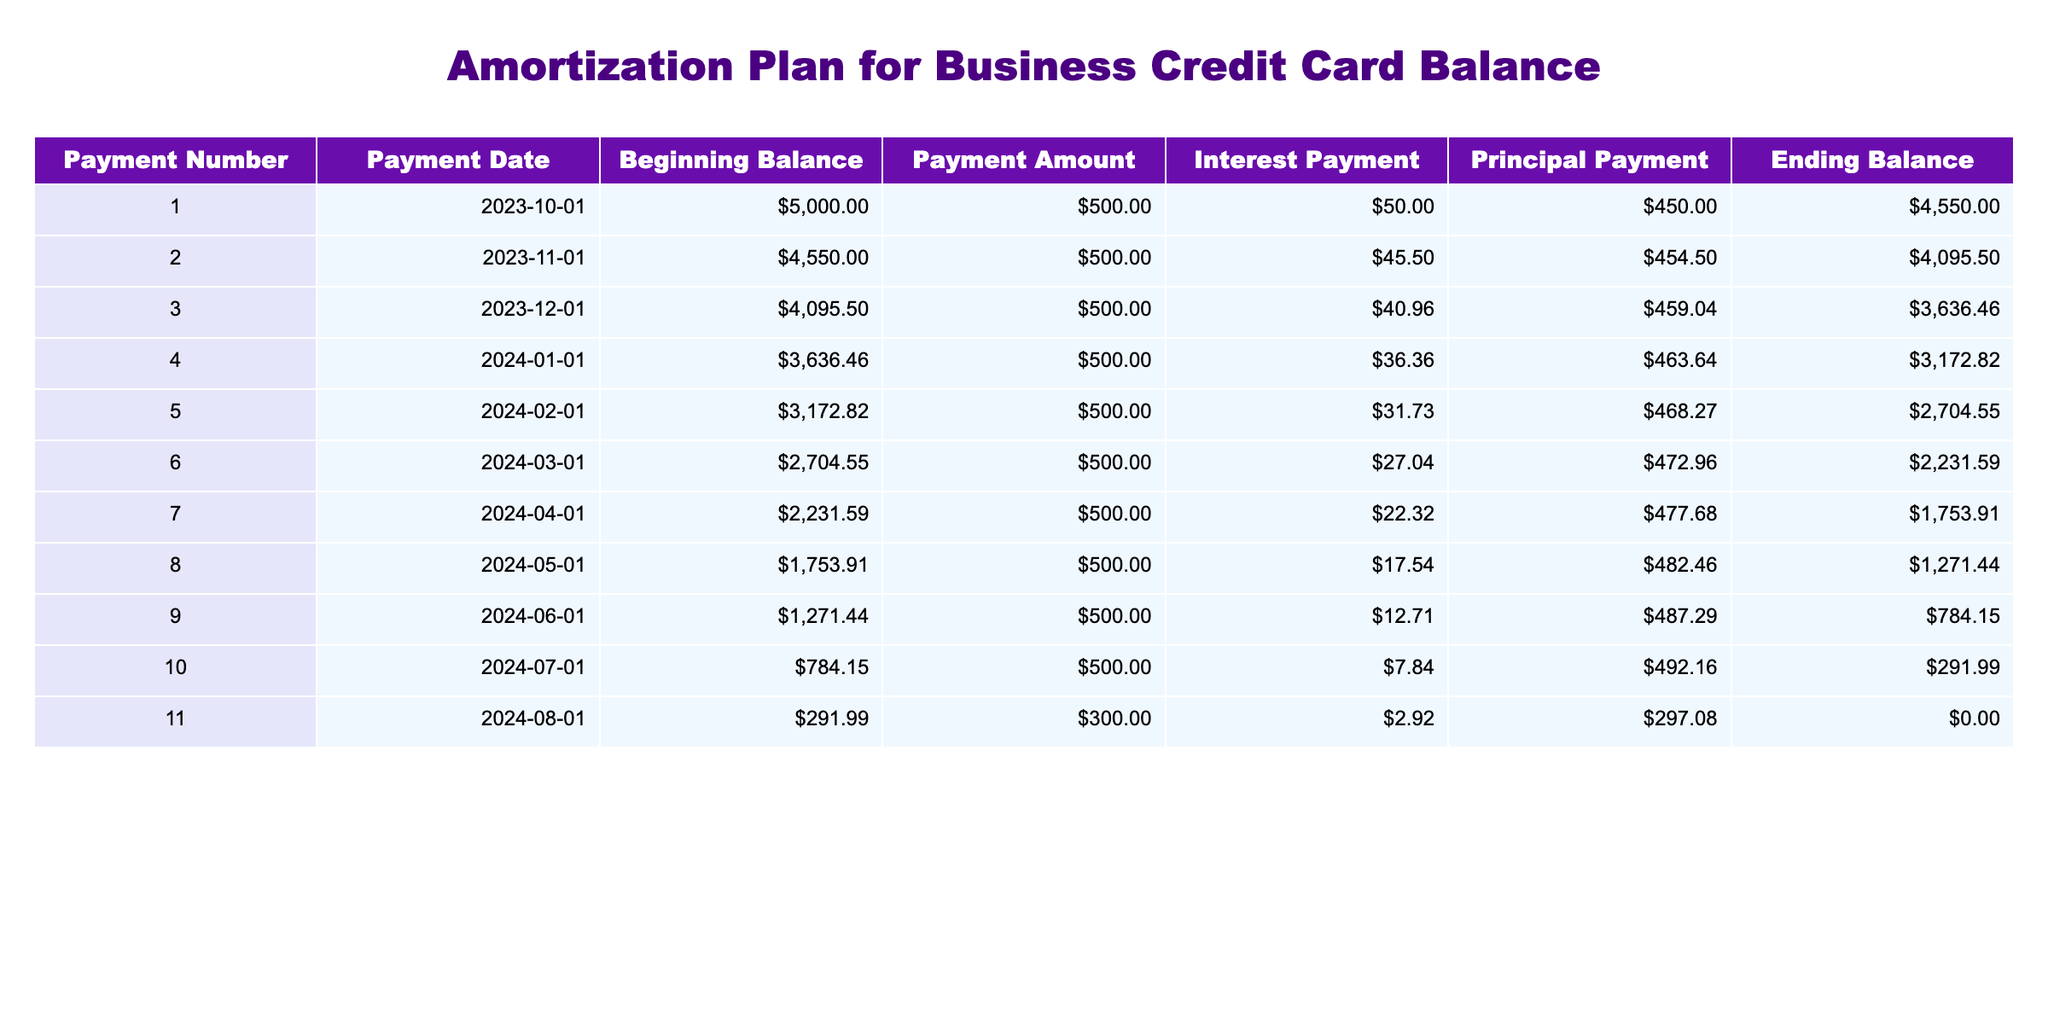What is the payment amount for the first payment? According to the table, the payment amount for Payment Number 1 is listed as $500.00 in the respective column.
Answer: $500.00 What is the total interest paid by the end of the 11 payments? To find the total interest paid, we sum up all the interest payments from each row. This gives us $50.00 + $45.50 + $40.96 + $36.36 + $31.73 + $27.04 + $22.32 + $17.54 + $12.71 + $7.84 + $2.92 = $345.92.
Answer: $345.92 Is the ending balance after the 10th payment greater than the beginning balance before the 10th payment? The ending balance after the 10th payment is $291.99, and the beginning balance before the 10th payment is $784.15. Since $291.99 is less than $784.15, the answer is false.
Answer: False What is the average principal payment over all payments? To calculate the average principal payment, we sum all the principal payments: $450.00 + $454.50 + $459.04 + $463.64 + $468.27 + $472.96 + $477.68 + $482.46 + $487.29 + $492.16 + $297.08 = $5,455.68. We then divide by the number of payments (11) to get the average: $5,455.68 / 11 = $496.87.
Answer: $496.87 How much was the ending balance after payment number 5? Referring to the table, the ending balance after Payment Number 5 is $2704.55, which is indicated in the respective column for that payment number.
Answer: $2704.55 Did the interest payment decrease with each successive payment? By observing the interest payment column, we can see that the amounts are $50.00, $45.50, $40.96, $36.36, $31.73, $27.04, $22.32, $17.54, $12.71, $7.84, and $2.92. This shows a pattern of decrease after each payment, confirming that interest payments consistently decreased.
Answer: Yes What is the difference between the total amount paid in the first two payments and the total interest paid in those payments? First, we sum the payment amounts for the first two payments: $500.00 + $500.00 = $1000.00. Then we sum the interest payments for these two: $50.00 + $45.50 = $95.50. Now calculating the difference: $1000.00 - $95.50 = $904.50.
Answer: $904.50 What is the final balance after payment number 11? According to the table, the ending balance after Payment Number 11 is $0.00, which indicates that the balance has been completely paid off.
Answer: $0.00 How does the principal payment in the 6th payment compare to the principal payment in the 4th payment? The principal payment in the 6th payment is $472.96, while in the 4th payment it is $463.64. Since $472.96 is greater than $463.64, the principal payment in the 6th payment is higher.
Answer: Higher 